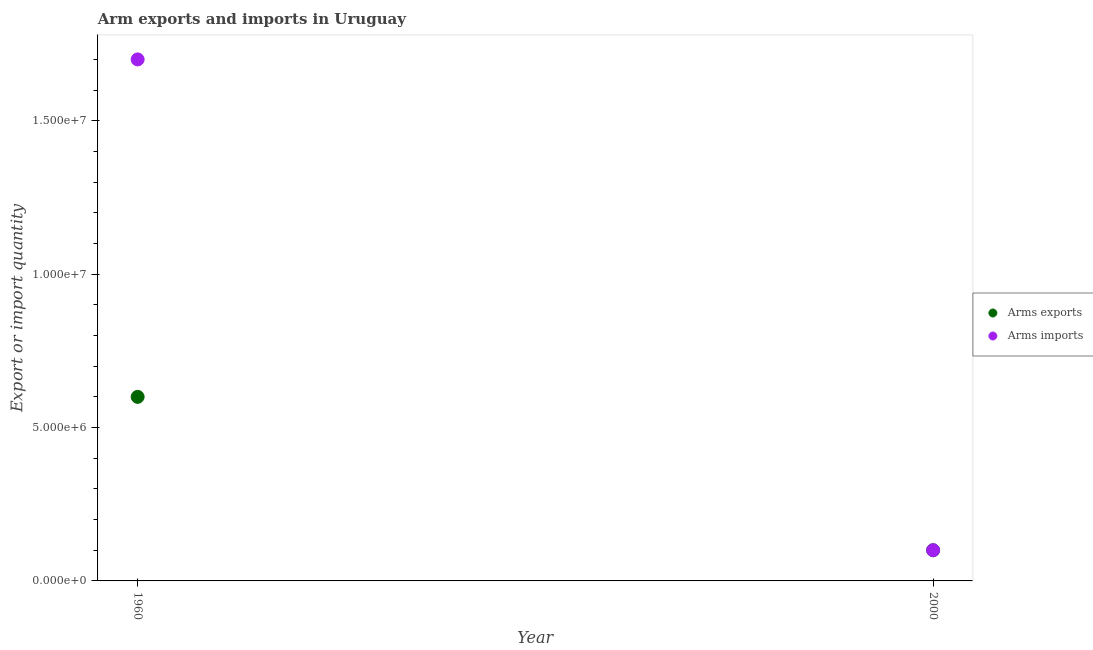Is the number of dotlines equal to the number of legend labels?
Make the answer very short. Yes. What is the arms exports in 2000?
Your answer should be compact. 1.00e+06. Across all years, what is the maximum arms imports?
Ensure brevity in your answer.  1.70e+07. Across all years, what is the minimum arms exports?
Make the answer very short. 1.00e+06. In which year was the arms imports maximum?
Provide a short and direct response. 1960. What is the total arms exports in the graph?
Offer a terse response. 7.00e+06. What is the difference between the arms exports in 1960 and that in 2000?
Provide a succinct answer. 5.00e+06. What is the difference between the arms exports in 1960 and the arms imports in 2000?
Offer a very short reply. 5.00e+06. What is the average arms imports per year?
Your response must be concise. 9.00e+06. In the year 1960, what is the difference between the arms exports and arms imports?
Ensure brevity in your answer.  -1.10e+07. In how many years, is the arms exports greater than 8000000?
Keep it short and to the point. 0. Does the arms exports monotonically increase over the years?
Your answer should be compact. No. Is the arms imports strictly greater than the arms exports over the years?
Your answer should be compact. No. How many legend labels are there?
Make the answer very short. 2. How are the legend labels stacked?
Provide a short and direct response. Vertical. What is the title of the graph?
Make the answer very short. Arm exports and imports in Uruguay. What is the label or title of the Y-axis?
Offer a terse response. Export or import quantity. What is the Export or import quantity of Arms imports in 1960?
Make the answer very short. 1.70e+07. What is the Export or import quantity of Arms exports in 2000?
Ensure brevity in your answer.  1.00e+06. Across all years, what is the maximum Export or import quantity of Arms imports?
Your answer should be very brief. 1.70e+07. Across all years, what is the minimum Export or import quantity of Arms exports?
Your answer should be very brief. 1.00e+06. Across all years, what is the minimum Export or import quantity of Arms imports?
Offer a very short reply. 1.00e+06. What is the total Export or import quantity in Arms exports in the graph?
Ensure brevity in your answer.  7.00e+06. What is the total Export or import quantity of Arms imports in the graph?
Your answer should be compact. 1.80e+07. What is the difference between the Export or import quantity of Arms exports in 1960 and that in 2000?
Make the answer very short. 5.00e+06. What is the difference between the Export or import quantity in Arms imports in 1960 and that in 2000?
Keep it short and to the point. 1.60e+07. What is the difference between the Export or import quantity of Arms exports in 1960 and the Export or import quantity of Arms imports in 2000?
Offer a very short reply. 5.00e+06. What is the average Export or import quantity in Arms exports per year?
Give a very brief answer. 3.50e+06. What is the average Export or import quantity in Arms imports per year?
Keep it short and to the point. 9.00e+06. In the year 1960, what is the difference between the Export or import quantity of Arms exports and Export or import quantity of Arms imports?
Give a very brief answer. -1.10e+07. In the year 2000, what is the difference between the Export or import quantity in Arms exports and Export or import quantity in Arms imports?
Make the answer very short. 0. What is the ratio of the Export or import quantity in Arms imports in 1960 to that in 2000?
Offer a terse response. 17. What is the difference between the highest and the second highest Export or import quantity in Arms exports?
Make the answer very short. 5.00e+06. What is the difference between the highest and the second highest Export or import quantity in Arms imports?
Provide a succinct answer. 1.60e+07. What is the difference between the highest and the lowest Export or import quantity of Arms exports?
Your answer should be compact. 5.00e+06. What is the difference between the highest and the lowest Export or import quantity in Arms imports?
Offer a very short reply. 1.60e+07. 